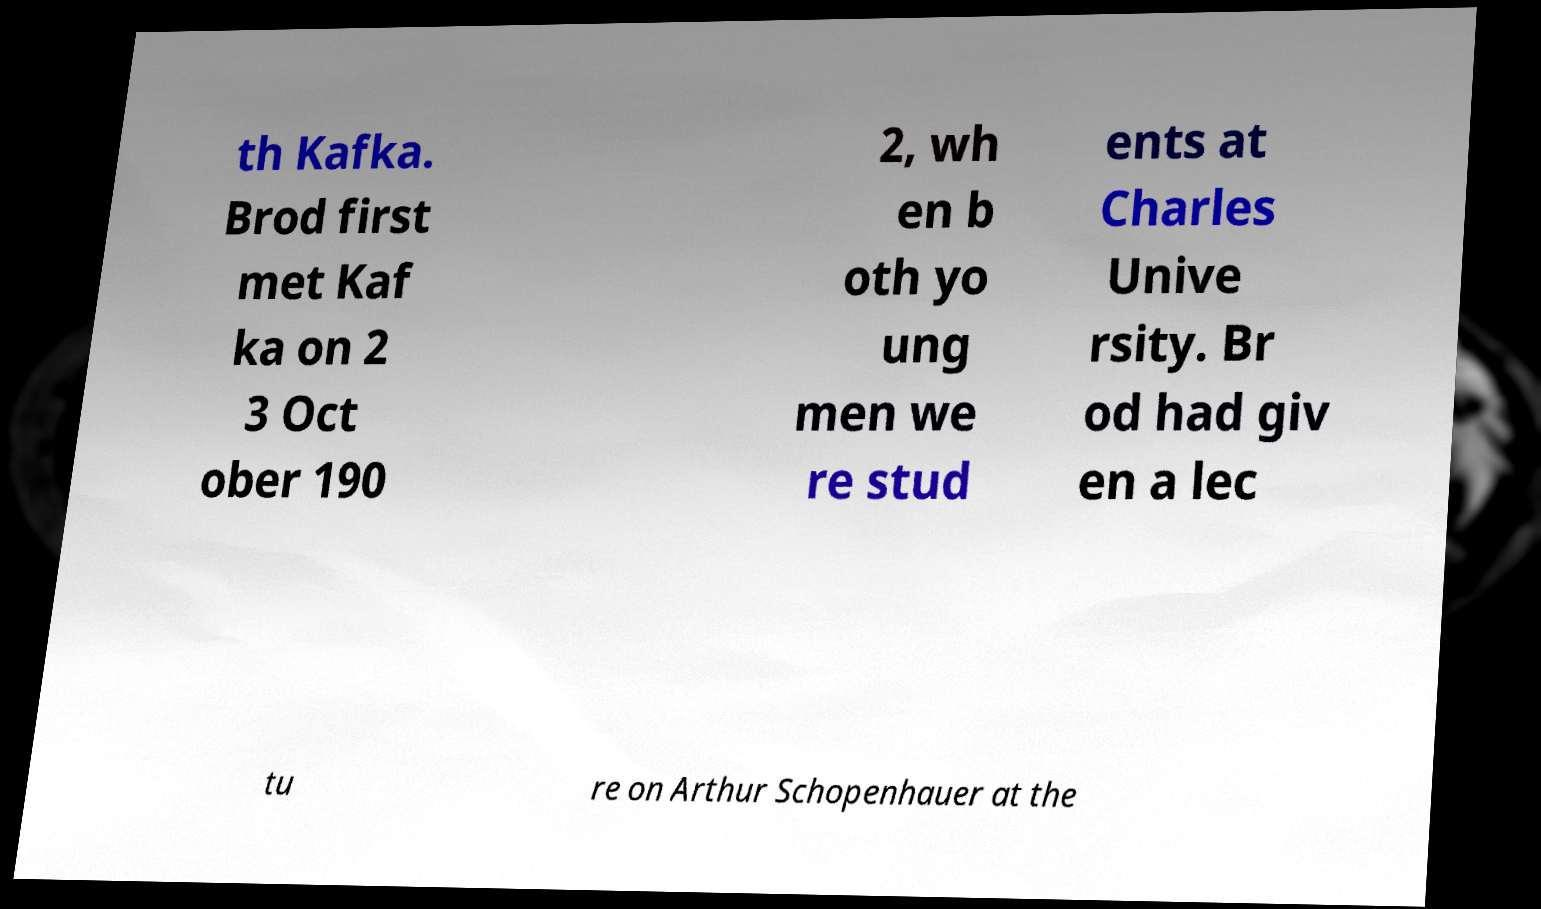Could you extract and type out the text from this image? th Kafka. Brod first met Kaf ka on 2 3 Oct ober 190 2, wh en b oth yo ung men we re stud ents at Charles Unive rsity. Br od had giv en a lec tu re on Arthur Schopenhauer at the 